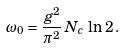Convert formula to latex. <formula><loc_0><loc_0><loc_500><loc_500>\omega _ { 0 } = \frac { g ^ { 2 } } { \pi ^ { 2 } } \, N _ { c } \, \ln \, 2 \, .</formula> 